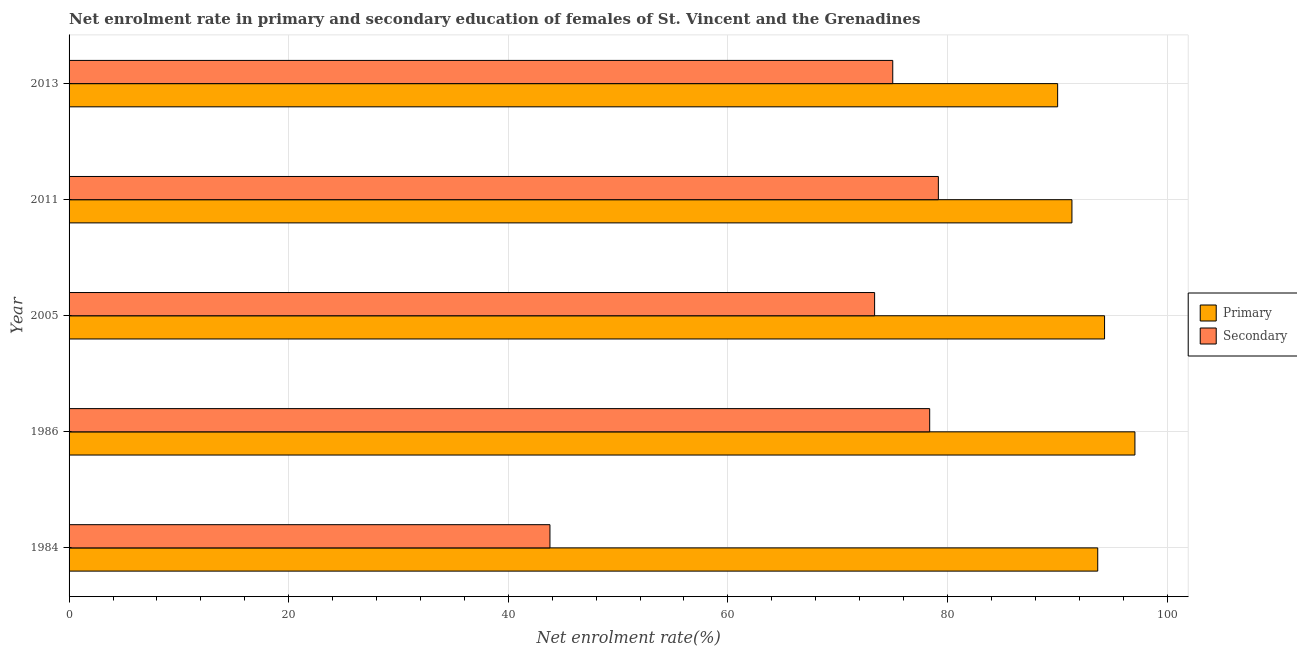How many different coloured bars are there?
Provide a succinct answer. 2. How many groups of bars are there?
Make the answer very short. 5. Are the number of bars per tick equal to the number of legend labels?
Keep it short and to the point. Yes. How many bars are there on the 2nd tick from the bottom?
Ensure brevity in your answer.  2. What is the enrollment rate in primary education in 2013?
Provide a succinct answer. 90.03. Across all years, what is the maximum enrollment rate in secondary education?
Your answer should be very brief. 79.17. Across all years, what is the minimum enrollment rate in primary education?
Provide a succinct answer. 90.03. In which year was the enrollment rate in primary education maximum?
Keep it short and to the point. 1986. What is the total enrollment rate in primary education in the graph?
Ensure brevity in your answer.  466.41. What is the difference between the enrollment rate in secondary education in 1984 and that in 2013?
Your answer should be compact. -31.22. What is the difference between the enrollment rate in primary education in 1984 and the enrollment rate in secondary education in 2011?
Make the answer very short. 14.51. What is the average enrollment rate in primary education per year?
Your answer should be compact. 93.28. In the year 2005, what is the difference between the enrollment rate in primary education and enrollment rate in secondary education?
Keep it short and to the point. 20.94. In how many years, is the enrollment rate in primary education greater than 28 %?
Your response must be concise. 5. What is the ratio of the enrollment rate in primary education in 1986 to that in 2011?
Your answer should be very brief. 1.06. Is the difference between the enrollment rate in secondary education in 1986 and 2013 greater than the difference between the enrollment rate in primary education in 1986 and 2013?
Your response must be concise. No. What is the difference between the highest and the second highest enrollment rate in primary education?
Your answer should be very brief. 2.77. What is the difference between the highest and the lowest enrollment rate in secondary education?
Give a very brief answer. 35.37. In how many years, is the enrollment rate in secondary education greater than the average enrollment rate in secondary education taken over all years?
Provide a succinct answer. 4. What does the 1st bar from the top in 1986 represents?
Your answer should be very brief. Secondary. What does the 2nd bar from the bottom in 2013 represents?
Offer a terse response. Secondary. How many bars are there?
Offer a very short reply. 10. Are all the bars in the graph horizontal?
Provide a short and direct response. Yes. Does the graph contain grids?
Give a very brief answer. Yes. Where does the legend appear in the graph?
Ensure brevity in your answer.  Center right. How are the legend labels stacked?
Make the answer very short. Vertical. What is the title of the graph?
Offer a very short reply. Net enrolment rate in primary and secondary education of females of St. Vincent and the Grenadines. Does "Male labourers" appear as one of the legend labels in the graph?
Offer a very short reply. No. What is the label or title of the X-axis?
Offer a very short reply. Net enrolment rate(%). What is the label or title of the Y-axis?
Ensure brevity in your answer.  Year. What is the Net enrolment rate(%) of Primary in 1984?
Keep it short and to the point. 93.68. What is the Net enrolment rate(%) in Secondary in 1984?
Provide a short and direct response. 43.79. What is the Net enrolment rate(%) in Primary in 1986?
Your answer should be compact. 97.07. What is the Net enrolment rate(%) of Secondary in 1986?
Give a very brief answer. 78.38. What is the Net enrolment rate(%) in Primary in 2005?
Give a very brief answer. 94.3. What is the Net enrolment rate(%) in Secondary in 2005?
Provide a short and direct response. 73.36. What is the Net enrolment rate(%) of Primary in 2011?
Keep it short and to the point. 91.33. What is the Net enrolment rate(%) of Secondary in 2011?
Give a very brief answer. 79.17. What is the Net enrolment rate(%) in Primary in 2013?
Give a very brief answer. 90.03. What is the Net enrolment rate(%) in Secondary in 2013?
Give a very brief answer. 75.01. Across all years, what is the maximum Net enrolment rate(%) of Primary?
Provide a short and direct response. 97.07. Across all years, what is the maximum Net enrolment rate(%) of Secondary?
Keep it short and to the point. 79.17. Across all years, what is the minimum Net enrolment rate(%) in Primary?
Keep it short and to the point. 90.03. Across all years, what is the minimum Net enrolment rate(%) in Secondary?
Offer a very short reply. 43.79. What is the total Net enrolment rate(%) in Primary in the graph?
Provide a succinct answer. 466.41. What is the total Net enrolment rate(%) of Secondary in the graph?
Your response must be concise. 349.71. What is the difference between the Net enrolment rate(%) in Primary in 1984 and that in 1986?
Provide a succinct answer. -3.39. What is the difference between the Net enrolment rate(%) of Secondary in 1984 and that in 1986?
Offer a terse response. -34.58. What is the difference between the Net enrolment rate(%) in Primary in 1984 and that in 2005?
Give a very brief answer. -0.62. What is the difference between the Net enrolment rate(%) in Secondary in 1984 and that in 2005?
Your answer should be compact. -29.57. What is the difference between the Net enrolment rate(%) in Primary in 1984 and that in 2011?
Offer a terse response. 2.35. What is the difference between the Net enrolment rate(%) in Secondary in 1984 and that in 2011?
Offer a terse response. -35.37. What is the difference between the Net enrolment rate(%) of Primary in 1984 and that in 2013?
Offer a very short reply. 3.65. What is the difference between the Net enrolment rate(%) in Secondary in 1984 and that in 2013?
Ensure brevity in your answer.  -31.22. What is the difference between the Net enrolment rate(%) of Primary in 1986 and that in 2005?
Ensure brevity in your answer.  2.76. What is the difference between the Net enrolment rate(%) of Secondary in 1986 and that in 2005?
Your answer should be very brief. 5.02. What is the difference between the Net enrolment rate(%) of Primary in 1986 and that in 2011?
Keep it short and to the point. 5.74. What is the difference between the Net enrolment rate(%) of Secondary in 1986 and that in 2011?
Ensure brevity in your answer.  -0.79. What is the difference between the Net enrolment rate(%) in Primary in 1986 and that in 2013?
Ensure brevity in your answer.  7.04. What is the difference between the Net enrolment rate(%) of Secondary in 1986 and that in 2013?
Your answer should be very brief. 3.36. What is the difference between the Net enrolment rate(%) in Primary in 2005 and that in 2011?
Your answer should be very brief. 2.97. What is the difference between the Net enrolment rate(%) in Secondary in 2005 and that in 2011?
Give a very brief answer. -5.81. What is the difference between the Net enrolment rate(%) of Primary in 2005 and that in 2013?
Make the answer very short. 4.27. What is the difference between the Net enrolment rate(%) in Secondary in 2005 and that in 2013?
Ensure brevity in your answer.  -1.65. What is the difference between the Net enrolment rate(%) of Primary in 2011 and that in 2013?
Give a very brief answer. 1.3. What is the difference between the Net enrolment rate(%) of Secondary in 2011 and that in 2013?
Provide a short and direct response. 4.15. What is the difference between the Net enrolment rate(%) of Primary in 1984 and the Net enrolment rate(%) of Secondary in 1986?
Your response must be concise. 15.3. What is the difference between the Net enrolment rate(%) of Primary in 1984 and the Net enrolment rate(%) of Secondary in 2005?
Make the answer very short. 20.32. What is the difference between the Net enrolment rate(%) in Primary in 1984 and the Net enrolment rate(%) in Secondary in 2011?
Provide a short and direct response. 14.51. What is the difference between the Net enrolment rate(%) of Primary in 1984 and the Net enrolment rate(%) of Secondary in 2013?
Provide a short and direct response. 18.67. What is the difference between the Net enrolment rate(%) of Primary in 1986 and the Net enrolment rate(%) of Secondary in 2005?
Your response must be concise. 23.71. What is the difference between the Net enrolment rate(%) of Primary in 1986 and the Net enrolment rate(%) of Secondary in 2011?
Make the answer very short. 17.9. What is the difference between the Net enrolment rate(%) of Primary in 1986 and the Net enrolment rate(%) of Secondary in 2013?
Provide a succinct answer. 22.05. What is the difference between the Net enrolment rate(%) of Primary in 2005 and the Net enrolment rate(%) of Secondary in 2011?
Provide a succinct answer. 15.14. What is the difference between the Net enrolment rate(%) in Primary in 2005 and the Net enrolment rate(%) in Secondary in 2013?
Your answer should be compact. 19.29. What is the difference between the Net enrolment rate(%) of Primary in 2011 and the Net enrolment rate(%) of Secondary in 2013?
Your response must be concise. 16.32. What is the average Net enrolment rate(%) of Primary per year?
Ensure brevity in your answer.  93.28. What is the average Net enrolment rate(%) of Secondary per year?
Keep it short and to the point. 69.94. In the year 1984, what is the difference between the Net enrolment rate(%) in Primary and Net enrolment rate(%) in Secondary?
Your answer should be very brief. 49.89. In the year 1986, what is the difference between the Net enrolment rate(%) of Primary and Net enrolment rate(%) of Secondary?
Provide a short and direct response. 18.69. In the year 2005, what is the difference between the Net enrolment rate(%) in Primary and Net enrolment rate(%) in Secondary?
Provide a succinct answer. 20.94. In the year 2011, what is the difference between the Net enrolment rate(%) in Primary and Net enrolment rate(%) in Secondary?
Give a very brief answer. 12.16. In the year 2013, what is the difference between the Net enrolment rate(%) of Primary and Net enrolment rate(%) of Secondary?
Offer a terse response. 15.02. What is the ratio of the Net enrolment rate(%) in Primary in 1984 to that in 1986?
Offer a terse response. 0.97. What is the ratio of the Net enrolment rate(%) of Secondary in 1984 to that in 1986?
Ensure brevity in your answer.  0.56. What is the ratio of the Net enrolment rate(%) in Primary in 1984 to that in 2005?
Your response must be concise. 0.99. What is the ratio of the Net enrolment rate(%) of Secondary in 1984 to that in 2005?
Ensure brevity in your answer.  0.6. What is the ratio of the Net enrolment rate(%) of Primary in 1984 to that in 2011?
Ensure brevity in your answer.  1.03. What is the ratio of the Net enrolment rate(%) in Secondary in 1984 to that in 2011?
Your answer should be compact. 0.55. What is the ratio of the Net enrolment rate(%) of Primary in 1984 to that in 2013?
Give a very brief answer. 1.04. What is the ratio of the Net enrolment rate(%) of Secondary in 1984 to that in 2013?
Your response must be concise. 0.58. What is the ratio of the Net enrolment rate(%) in Primary in 1986 to that in 2005?
Make the answer very short. 1.03. What is the ratio of the Net enrolment rate(%) of Secondary in 1986 to that in 2005?
Ensure brevity in your answer.  1.07. What is the ratio of the Net enrolment rate(%) in Primary in 1986 to that in 2011?
Provide a succinct answer. 1.06. What is the ratio of the Net enrolment rate(%) in Primary in 1986 to that in 2013?
Offer a terse response. 1.08. What is the ratio of the Net enrolment rate(%) of Secondary in 1986 to that in 2013?
Make the answer very short. 1.04. What is the ratio of the Net enrolment rate(%) of Primary in 2005 to that in 2011?
Give a very brief answer. 1.03. What is the ratio of the Net enrolment rate(%) of Secondary in 2005 to that in 2011?
Make the answer very short. 0.93. What is the ratio of the Net enrolment rate(%) of Primary in 2005 to that in 2013?
Provide a short and direct response. 1.05. What is the ratio of the Net enrolment rate(%) in Secondary in 2005 to that in 2013?
Provide a short and direct response. 0.98. What is the ratio of the Net enrolment rate(%) of Primary in 2011 to that in 2013?
Keep it short and to the point. 1.01. What is the ratio of the Net enrolment rate(%) in Secondary in 2011 to that in 2013?
Offer a terse response. 1.06. What is the difference between the highest and the second highest Net enrolment rate(%) of Primary?
Give a very brief answer. 2.76. What is the difference between the highest and the second highest Net enrolment rate(%) of Secondary?
Offer a very short reply. 0.79. What is the difference between the highest and the lowest Net enrolment rate(%) of Primary?
Offer a terse response. 7.04. What is the difference between the highest and the lowest Net enrolment rate(%) of Secondary?
Your answer should be very brief. 35.37. 